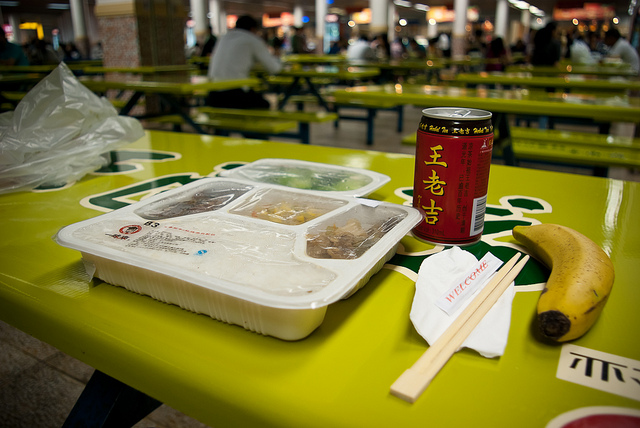<image>What brand of soda is served at this restaurant? I am not certain what brand of soda is served at this restaurant. It could be 'coke', 'jia duo bao' or some 'chinese brand'. What brand of soda is served at this restaurant? I don't know what brand of soda is served at this restaurant. It can be 'coke', 'jia duo bao', 'chinese brand', 'coca cola', or 'taiwan'. 